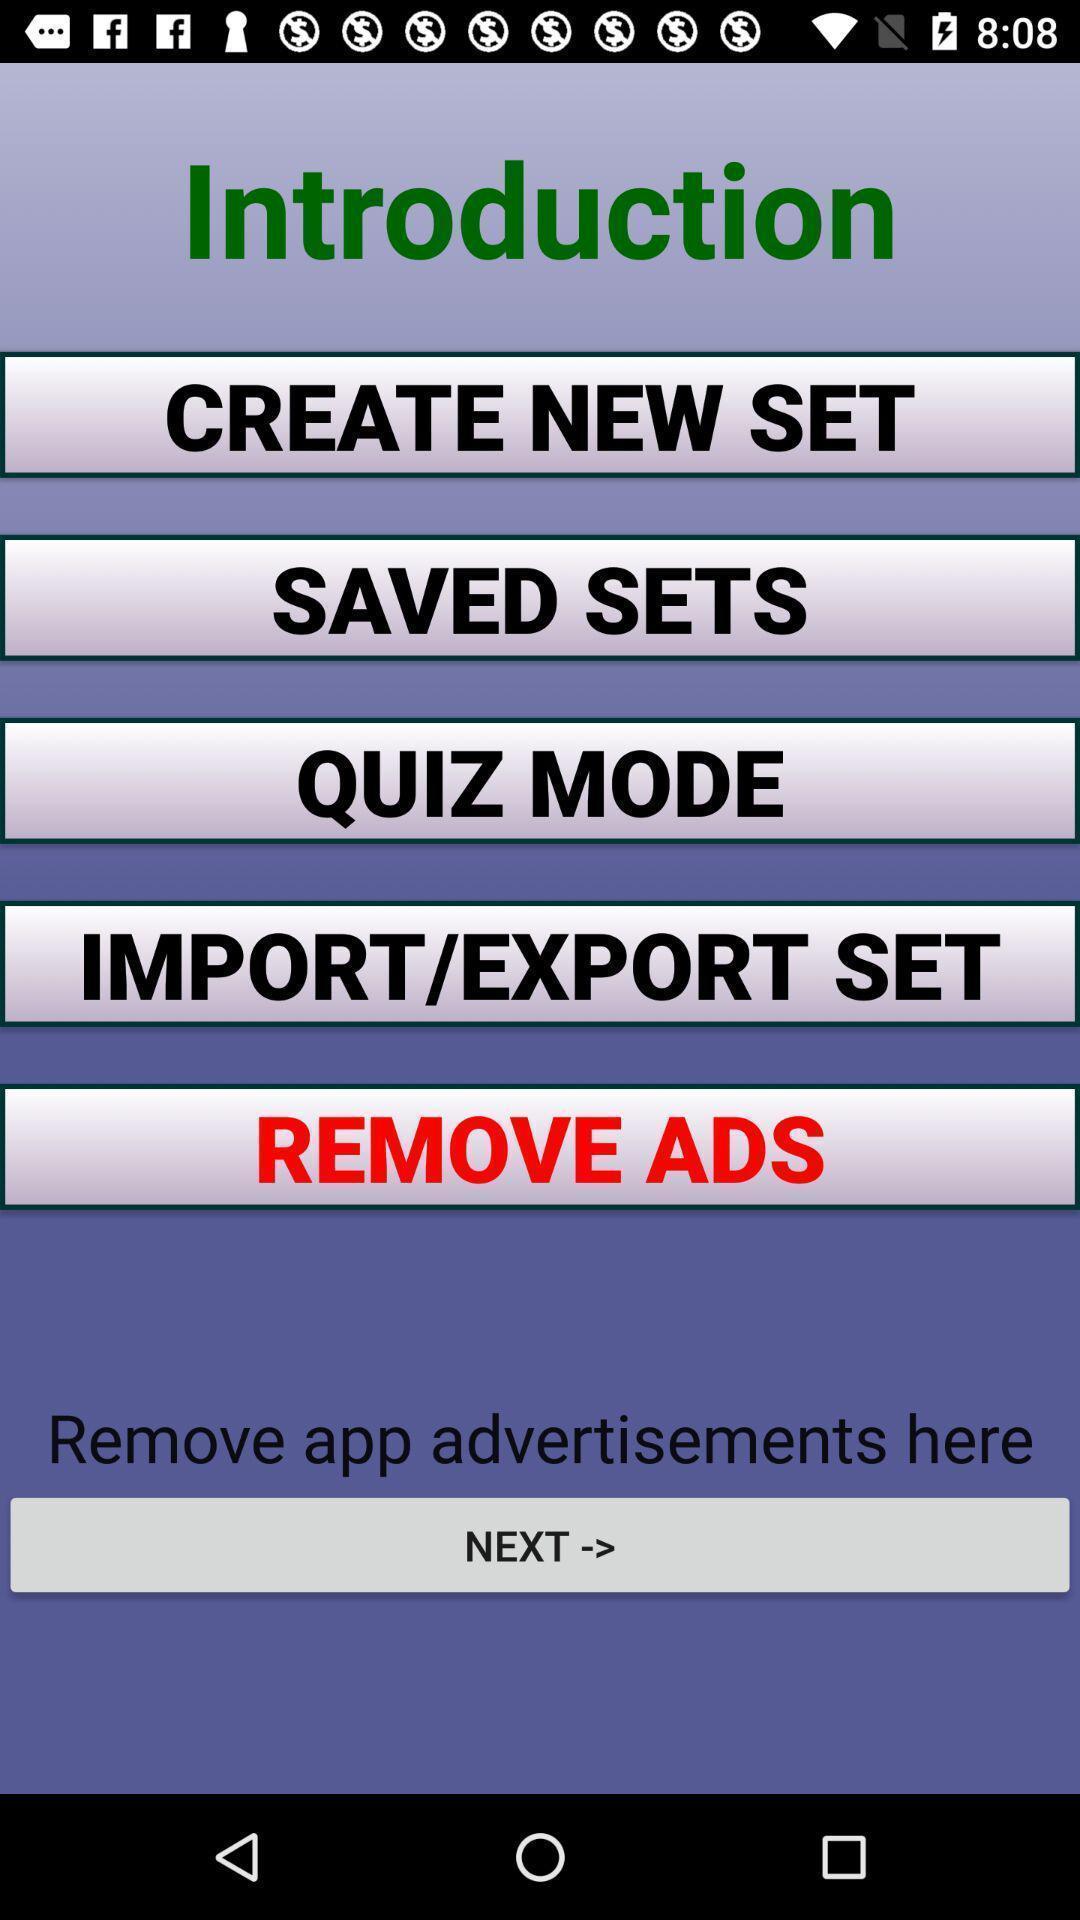Describe the visual elements of this screenshot. Welcome page of memorizing app. 